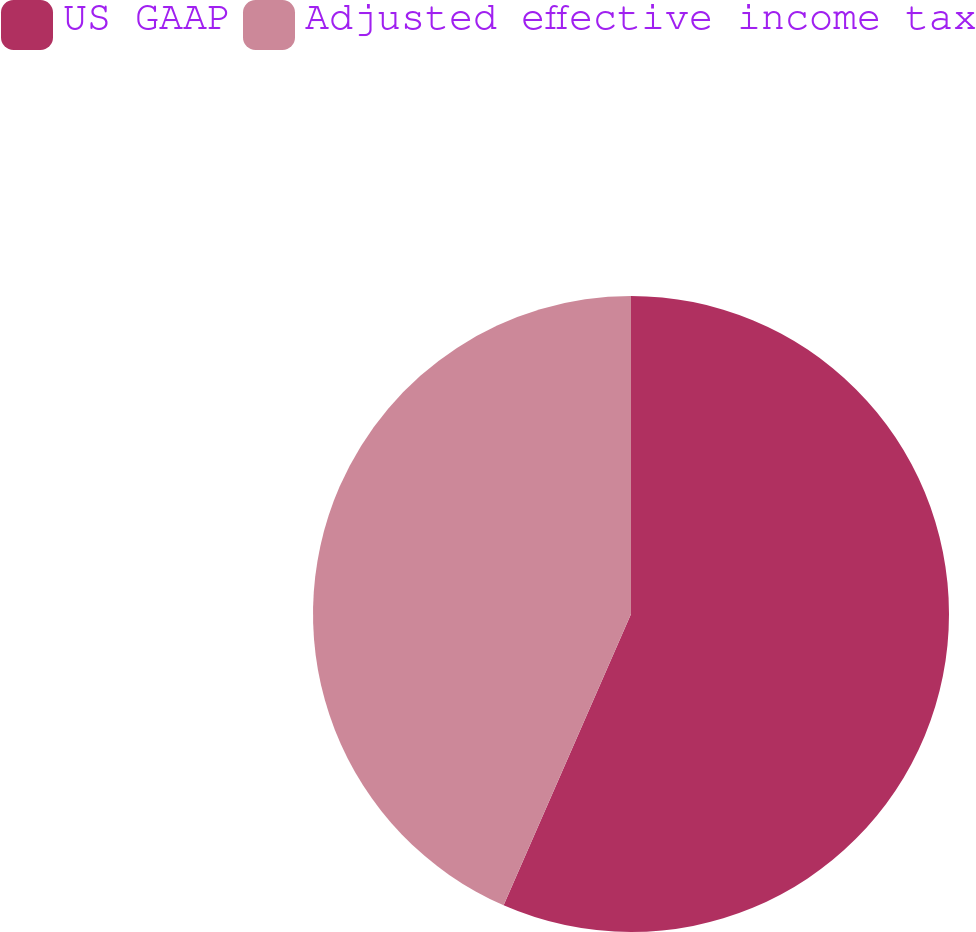Convert chart. <chart><loc_0><loc_0><loc_500><loc_500><pie_chart><fcel>US GAAP<fcel>Adjusted effective income tax<nl><fcel>56.56%<fcel>43.44%<nl></chart> 